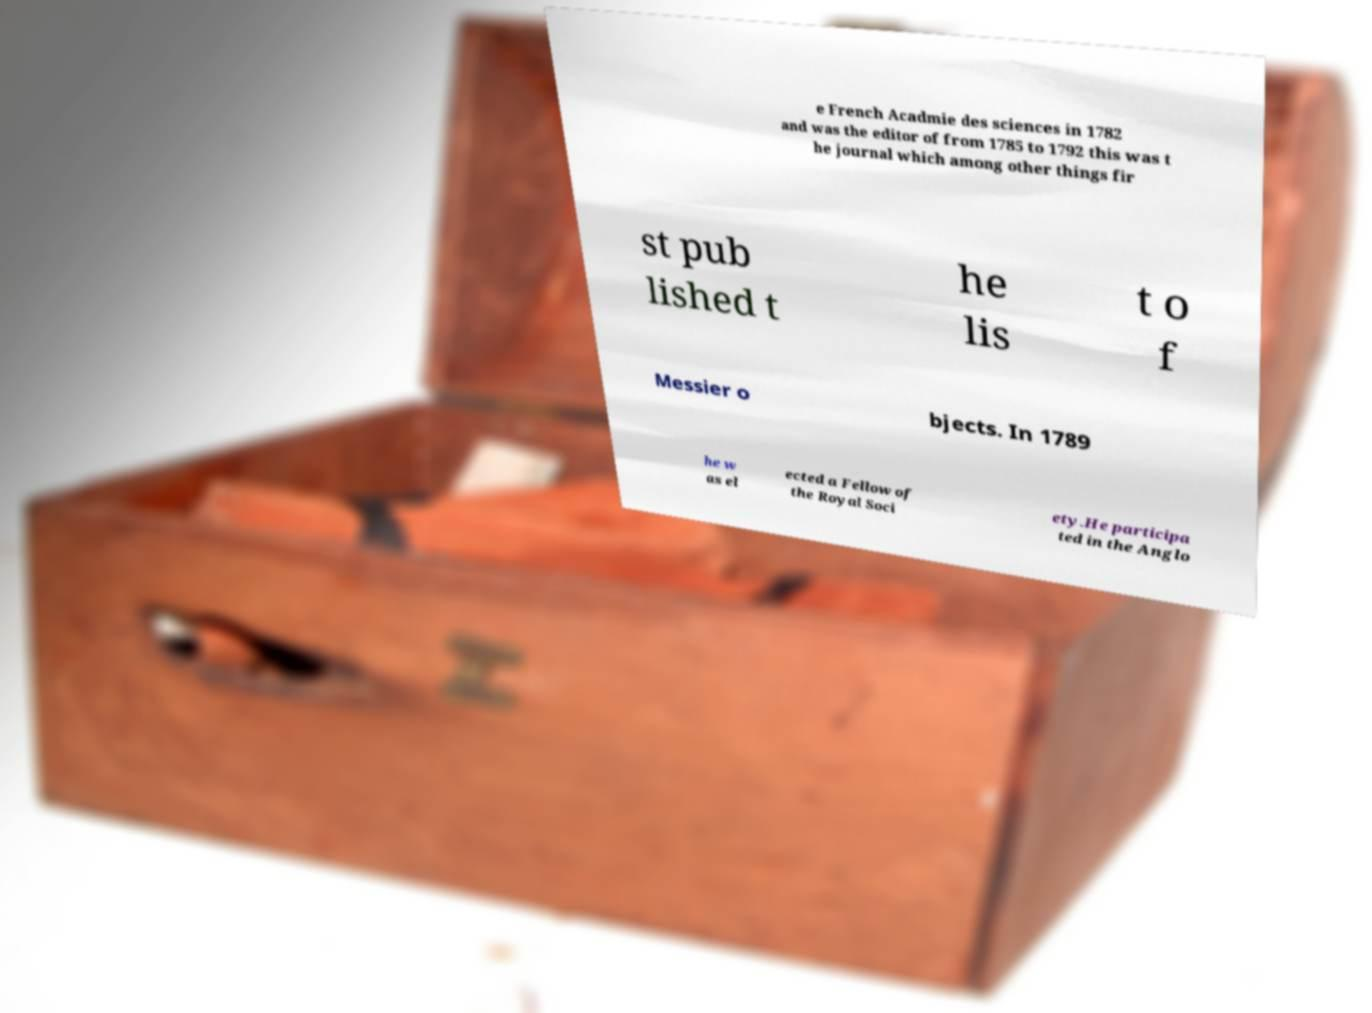For documentation purposes, I need the text within this image transcribed. Could you provide that? e French Acadmie des sciences in 1782 and was the editor of from 1785 to 1792 this was t he journal which among other things fir st pub lished t he lis t o f Messier o bjects. In 1789 he w as el ected a Fellow of the Royal Soci ety.He participa ted in the Anglo 